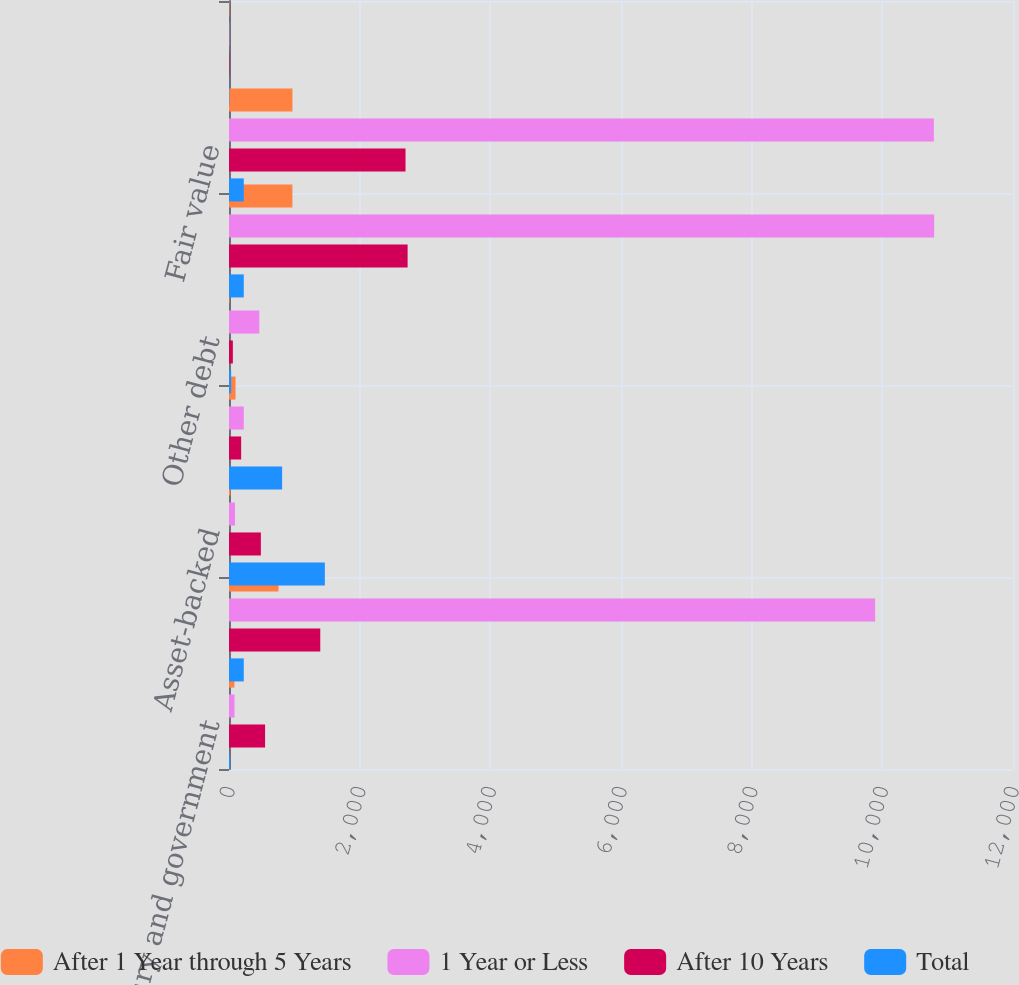Convert chart. <chart><loc_0><loc_0><loc_500><loc_500><stacked_bar_chart><ecel><fcel>US Treasury and government<fcel>Residential mortgage-backed<fcel>Asset-backed<fcel>State and municipal<fcel>Other debt<fcel>Total debt securities<fcel>Fair value<fcel>Weighted-average yield GAAP<nl><fcel>After 1 Year through 5 Years<fcel>83<fcel>758<fcel>22<fcel>100<fcel>7<fcel>970<fcel>971<fcel>6.09<nl><fcel>1 Year or Less<fcel>84<fcel>9890<fcel>92<fcel>226<fcel>464<fcel>10793<fcel>10789<fcel>5.02<nl><fcel>After 10 Years<fcel>552<fcel>1397<fcel>488<fcel>186<fcel>59<fcel>2734<fcel>2702<fcel>6.06<nl><fcel>Total<fcel>19<fcel>226<fcel>1467<fcel>813<fcel>33<fcel>226<fcel>226<fcel>5.53<nl></chart> 